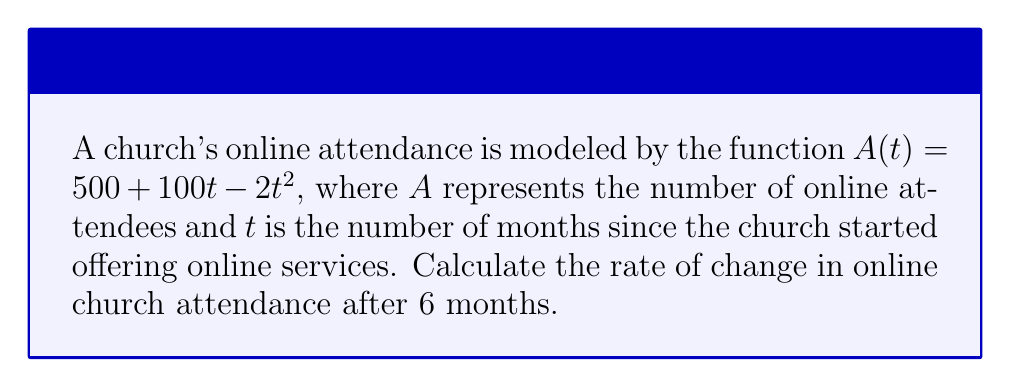Teach me how to tackle this problem. To find the rate of change in online church attendance after 6 months, we need to calculate the derivative of the given function $A(t)$ and then evaluate it at $t=6$.

Step 1: Find the derivative of $A(t)$
$$A(t) = 500 + 100t - 2t^2$$
$$A'(t) = 100 - 4t$$

Step 2: Evaluate $A'(t)$ at $t=6$
$$A'(6) = 100 - 4(6)$$
$$A'(6) = 100 - 24$$
$$A'(6) = 76$$

The rate of change is 76 attendees per month after 6 months. The positive value indicates that attendance is still increasing, but at a slower rate than initially.

This analysis can help church leaders understand the growth trend of their online services and make informed decisions about resource allocation and engagement strategies in the digital space.
Answer: $76$ attendees per month 